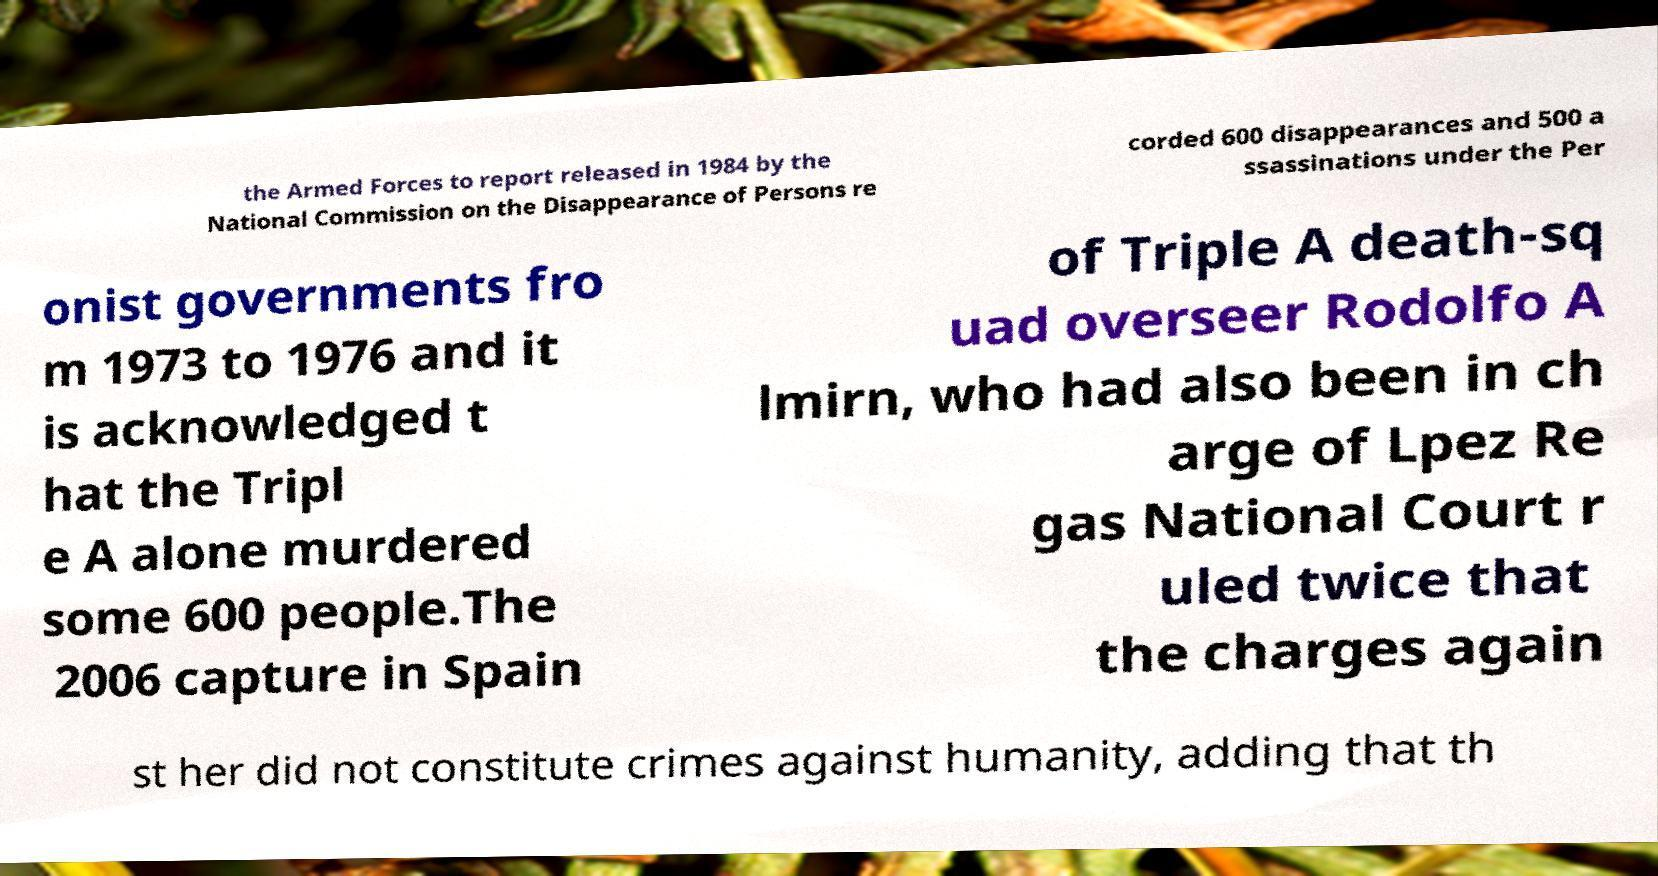Please read and relay the text visible in this image. What does it say? the Armed Forces to report released in 1984 by the National Commission on the Disappearance of Persons re corded 600 disappearances and 500 a ssassinations under the Per onist governments fro m 1973 to 1976 and it is acknowledged t hat the Tripl e A alone murdered some 600 people.The 2006 capture in Spain of Triple A death-sq uad overseer Rodolfo A lmirn, who had also been in ch arge of Lpez Re gas National Court r uled twice that the charges again st her did not constitute crimes against humanity, adding that th 